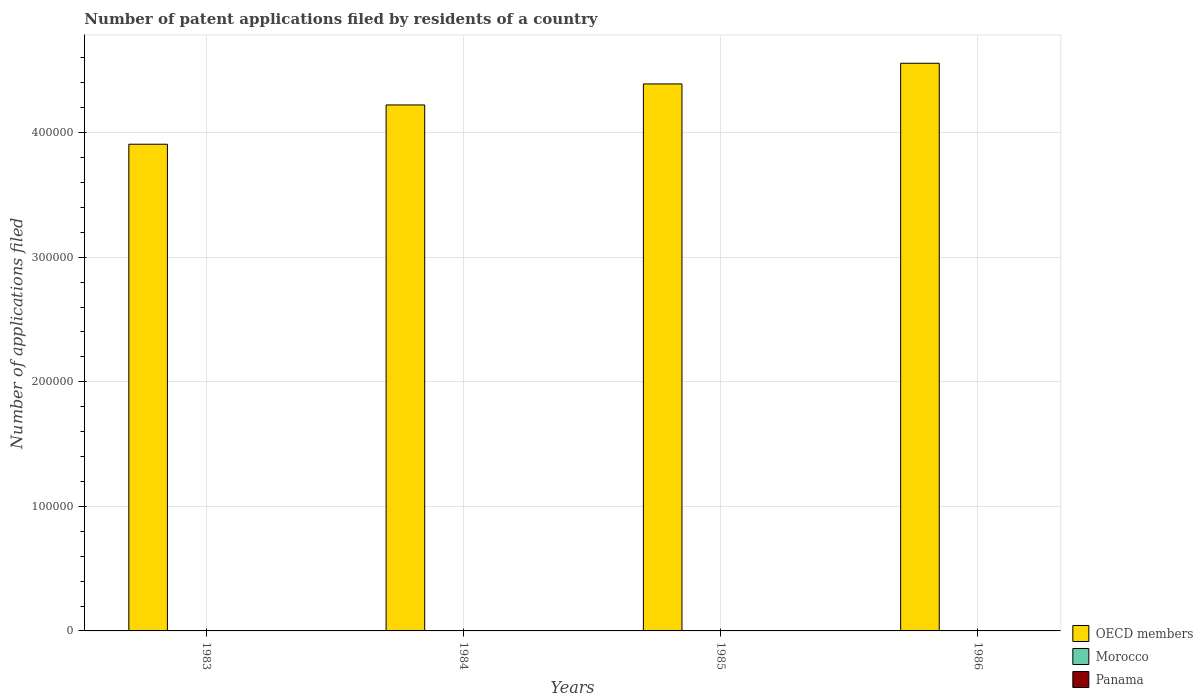Are the number of bars per tick equal to the number of legend labels?
Keep it short and to the point. Yes. Are the number of bars on each tick of the X-axis equal?
Make the answer very short. Yes. How many bars are there on the 3rd tick from the left?
Your answer should be very brief. 3. What is the label of the 2nd group of bars from the left?
Provide a succinct answer. 1984. Across all years, what is the maximum number of applications filed in Panama?
Make the answer very short. 16. Across all years, what is the minimum number of applications filed in OECD members?
Ensure brevity in your answer.  3.91e+05. In which year was the number of applications filed in Morocco minimum?
Your response must be concise. 1983. What is the total number of applications filed in OECD members in the graph?
Make the answer very short. 1.71e+06. In how many years, is the number of applications filed in Panama greater than 220000?
Your answer should be compact. 0. What is the ratio of the number of applications filed in OECD members in 1984 to that in 1985?
Offer a very short reply. 0.96. Is the difference between the number of applications filed in Morocco in 1984 and 1986 greater than the difference between the number of applications filed in Panama in 1984 and 1986?
Keep it short and to the point. No. Is the sum of the number of applications filed in OECD members in 1983 and 1985 greater than the maximum number of applications filed in Panama across all years?
Give a very brief answer. Yes. What does the 2nd bar from the left in 1984 represents?
Your answer should be compact. Morocco. What does the 3rd bar from the right in 1986 represents?
Your answer should be compact. OECD members. How many years are there in the graph?
Your response must be concise. 4. What is the difference between two consecutive major ticks on the Y-axis?
Ensure brevity in your answer.  1.00e+05. Are the values on the major ticks of Y-axis written in scientific E-notation?
Ensure brevity in your answer.  No. Does the graph contain grids?
Your answer should be very brief. Yes. Where does the legend appear in the graph?
Your answer should be compact. Bottom right. How are the legend labels stacked?
Provide a succinct answer. Vertical. What is the title of the graph?
Your answer should be compact. Number of patent applications filed by residents of a country. Does "Senegal" appear as one of the legend labels in the graph?
Make the answer very short. No. What is the label or title of the X-axis?
Offer a terse response. Years. What is the label or title of the Y-axis?
Provide a succinct answer. Number of applications filed. What is the Number of applications filed in OECD members in 1983?
Your response must be concise. 3.91e+05. What is the Number of applications filed of Panama in 1983?
Your response must be concise. 16. What is the Number of applications filed of OECD members in 1984?
Give a very brief answer. 4.22e+05. What is the Number of applications filed in Morocco in 1984?
Ensure brevity in your answer.  28. What is the Number of applications filed in Panama in 1984?
Your response must be concise. 15. What is the Number of applications filed in OECD members in 1985?
Offer a very short reply. 4.39e+05. What is the Number of applications filed of Panama in 1985?
Offer a very short reply. 14. What is the Number of applications filed of OECD members in 1986?
Offer a terse response. 4.56e+05. What is the Number of applications filed in Panama in 1986?
Provide a short and direct response. 11. Across all years, what is the maximum Number of applications filed in OECD members?
Ensure brevity in your answer.  4.56e+05. Across all years, what is the maximum Number of applications filed in Panama?
Your response must be concise. 16. Across all years, what is the minimum Number of applications filed of OECD members?
Give a very brief answer. 3.91e+05. What is the total Number of applications filed of OECD members in the graph?
Offer a very short reply. 1.71e+06. What is the total Number of applications filed of Morocco in the graph?
Offer a very short reply. 108. What is the difference between the Number of applications filed in OECD members in 1983 and that in 1984?
Offer a terse response. -3.15e+04. What is the difference between the Number of applications filed in Morocco in 1983 and that in 1984?
Provide a succinct answer. -12. What is the difference between the Number of applications filed in OECD members in 1983 and that in 1985?
Give a very brief answer. -4.84e+04. What is the difference between the Number of applications filed in Morocco in 1983 and that in 1985?
Ensure brevity in your answer.  -19. What is the difference between the Number of applications filed of Panama in 1983 and that in 1985?
Give a very brief answer. 2. What is the difference between the Number of applications filed of OECD members in 1983 and that in 1986?
Your answer should be very brief. -6.50e+04. What is the difference between the Number of applications filed in Morocco in 1983 and that in 1986?
Provide a succinct answer. -13. What is the difference between the Number of applications filed in OECD members in 1984 and that in 1985?
Make the answer very short. -1.69e+04. What is the difference between the Number of applications filed in Panama in 1984 and that in 1985?
Make the answer very short. 1. What is the difference between the Number of applications filed in OECD members in 1984 and that in 1986?
Your answer should be very brief. -3.35e+04. What is the difference between the Number of applications filed in OECD members in 1985 and that in 1986?
Offer a very short reply. -1.66e+04. What is the difference between the Number of applications filed in Morocco in 1985 and that in 1986?
Offer a very short reply. 6. What is the difference between the Number of applications filed in OECD members in 1983 and the Number of applications filed in Morocco in 1984?
Provide a succinct answer. 3.91e+05. What is the difference between the Number of applications filed of OECD members in 1983 and the Number of applications filed of Panama in 1984?
Provide a succinct answer. 3.91e+05. What is the difference between the Number of applications filed in OECD members in 1983 and the Number of applications filed in Morocco in 1985?
Provide a short and direct response. 3.91e+05. What is the difference between the Number of applications filed in OECD members in 1983 and the Number of applications filed in Panama in 1985?
Offer a very short reply. 3.91e+05. What is the difference between the Number of applications filed in Morocco in 1983 and the Number of applications filed in Panama in 1985?
Make the answer very short. 2. What is the difference between the Number of applications filed in OECD members in 1983 and the Number of applications filed in Morocco in 1986?
Your answer should be very brief. 3.91e+05. What is the difference between the Number of applications filed of OECD members in 1983 and the Number of applications filed of Panama in 1986?
Offer a terse response. 3.91e+05. What is the difference between the Number of applications filed of OECD members in 1984 and the Number of applications filed of Morocco in 1985?
Ensure brevity in your answer.  4.22e+05. What is the difference between the Number of applications filed in OECD members in 1984 and the Number of applications filed in Panama in 1985?
Offer a very short reply. 4.22e+05. What is the difference between the Number of applications filed of OECD members in 1984 and the Number of applications filed of Morocco in 1986?
Your response must be concise. 4.22e+05. What is the difference between the Number of applications filed of OECD members in 1984 and the Number of applications filed of Panama in 1986?
Your answer should be compact. 4.22e+05. What is the difference between the Number of applications filed of OECD members in 1985 and the Number of applications filed of Morocco in 1986?
Make the answer very short. 4.39e+05. What is the difference between the Number of applications filed of OECD members in 1985 and the Number of applications filed of Panama in 1986?
Your answer should be compact. 4.39e+05. What is the average Number of applications filed in OECD members per year?
Your answer should be compact. 4.27e+05. In the year 1983, what is the difference between the Number of applications filed of OECD members and Number of applications filed of Morocco?
Provide a short and direct response. 3.91e+05. In the year 1983, what is the difference between the Number of applications filed of OECD members and Number of applications filed of Panama?
Ensure brevity in your answer.  3.91e+05. In the year 1984, what is the difference between the Number of applications filed of OECD members and Number of applications filed of Morocco?
Give a very brief answer. 4.22e+05. In the year 1984, what is the difference between the Number of applications filed of OECD members and Number of applications filed of Panama?
Your answer should be very brief. 4.22e+05. In the year 1984, what is the difference between the Number of applications filed in Morocco and Number of applications filed in Panama?
Offer a very short reply. 13. In the year 1985, what is the difference between the Number of applications filed in OECD members and Number of applications filed in Morocco?
Your answer should be compact. 4.39e+05. In the year 1985, what is the difference between the Number of applications filed in OECD members and Number of applications filed in Panama?
Your response must be concise. 4.39e+05. In the year 1985, what is the difference between the Number of applications filed of Morocco and Number of applications filed of Panama?
Your response must be concise. 21. In the year 1986, what is the difference between the Number of applications filed in OECD members and Number of applications filed in Morocco?
Provide a succinct answer. 4.56e+05. In the year 1986, what is the difference between the Number of applications filed in OECD members and Number of applications filed in Panama?
Offer a terse response. 4.56e+05. In the year 1986, what is the difference between the Number of applications filed of Morocco and Number of applications filed of Panama?
Your answer should be compact. 18. What is the ratio of the Number of applications filed of OECD members in 1983 to that in 1984?
Ensure brevity in your answer.  0.93. What is the ratio of the Number of applications filed in Morocco in 1983 to that in 1984?
Your answer should be compact. 0.57. What is the ratio of the Number of applications filed in Panama in 1983 to that in 1984?
Ensure brevity in your answer.  1.07. What is the ratio of the Number of applications filed in OECD members in 1983 to that in 1985?
Provide a short and direct response. 0.89. What is the ratio of the Number of applications filed in Morocco in 1983 to that in 1985?
Your answer should be very brief. 0.46. What is the ratio of the Number of applications filed in OECD members in 1983 to that in 1986?
Your answer should be compact. 0.86. What is the ratio of the Number of applications filed of Morocco in 1983 to that in 1986?
Your answer should be very brief. 0.55. What is the ratio of the Number of applications filed in Panama in 1983 to that in 1986?
Your answer should be compact. 1.45. What is the ratio of the Number of applications filed in OECD members in 1984 to that in 1985?
Keep it short and to the point. 0.96. What is the ratio of the Number of applications filed in Panama in 1984 to that in 1985?
Your answer should be compact. 1.07. What is the ratio of the Number of applications filed in OECD members in 1984 to that in 1986?
Your answer should be compact. 0.93. What is the ratio of the Number of applications filed of Morocco in 1984 to that in 1986?
Make the answer very short. 0.97. What is the ratio of the Number of applications filed of Panama in 1984 to that in 1986?
Provide a succinct answer. 1.36. What is the ratio of the Number of applications filed of OECD members in 1985 to that in 1986?
Make the answer very short. 0.96. What is the ratio of the Number of applications filed of Morocco in 1985 to that in 1986?
Your response must be concise. 1.21. What is the ratio of the Number of applications filed of Panama in 1985 to that in 1986?
Your answer should be compact. 1.27. What is the difference between the highest and the second highest Number of applications filed of OECD members?
Give a very brief answer. 1.66e+04. What is the difference between the highest and the second highest Number of applications filed of Panama?
Give a very brief answer. 1. What is the difference between the highest and the lowest Number of applications filed of OECD members?
Offer a terse response. 6.50e+04. 